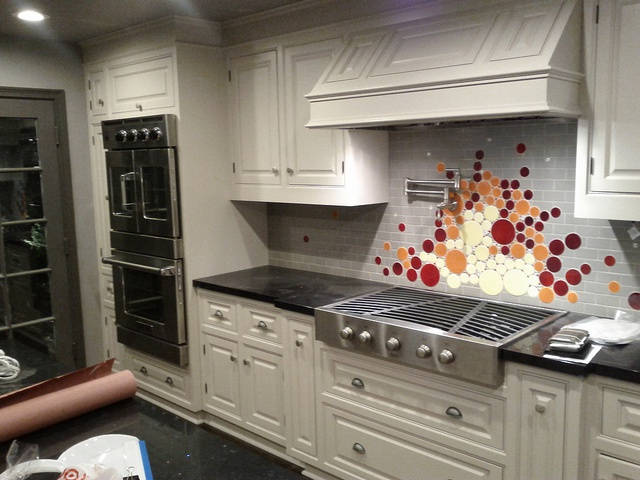Describe the objects in this image and their specific colors. I can see oven in black and gray tones and oven in black, gray, and darkgray tones in this image. 